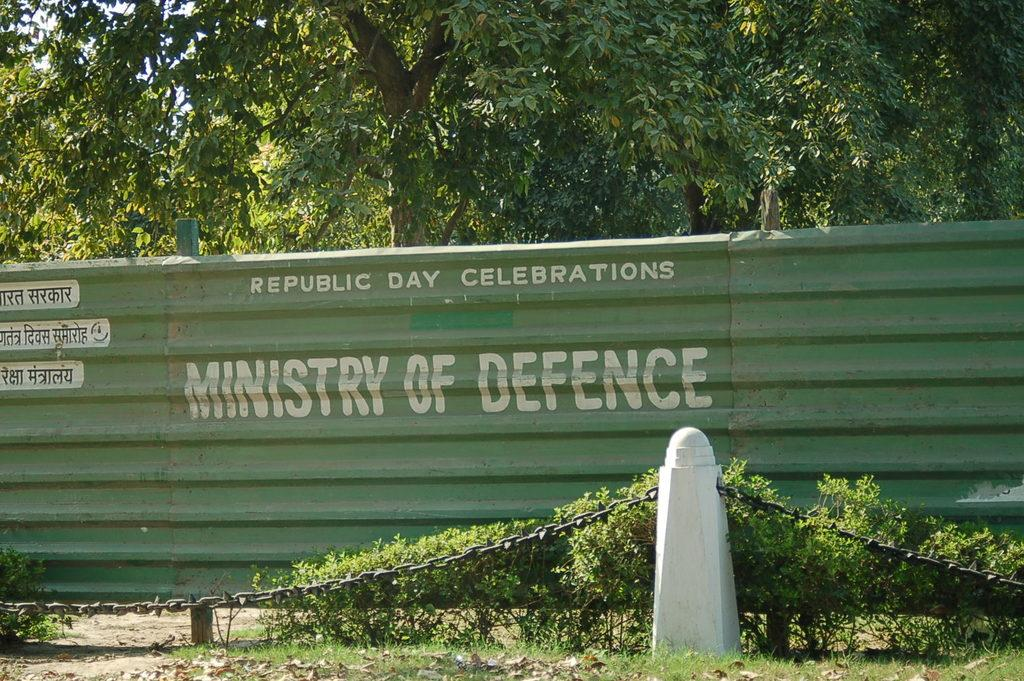What is the main feature of the fencing wall in the image? The fencing wall in the image has text on it. What is attached to the barrier rod in the image? A chain is attached to the barrier rod in the image. What type of vegetation can be seen in the image? Plants, grass, and trees are visible in the image. What is the condition of the ground in the image? Dried leaves are visible on the ground in the image. What type of instrument is being played by the trees in the image? There are no instruments or people playing them in the image; it features a fencing wall, barrier rod, chain, plants, grass, and trees. What type of drug can be seen being administered to the plants in the image? There is no drug or drug administration activity present in the image; it features a fencing wall, barrier rod, chain, plants, grass, and trees. 